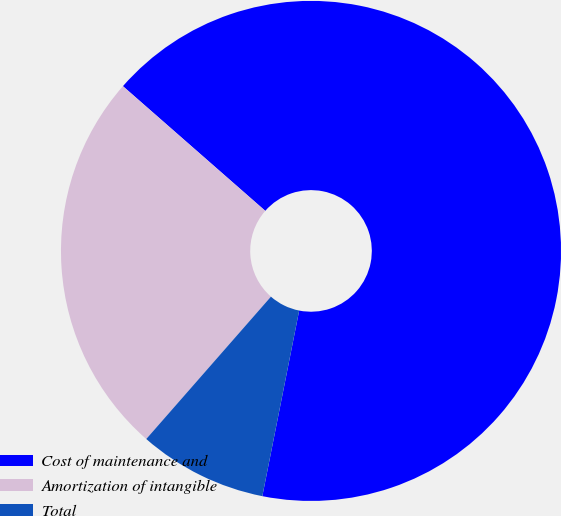<chart> <loc_0><loc_0><loc_500><loc_500><pie_chart><fcel>Cost of maintenance and<fcel>Amortization of intangible<fcel>Total<nl><fcel>66.67%<fcel>25.0%<fcel>8.33%<nl></chart> 